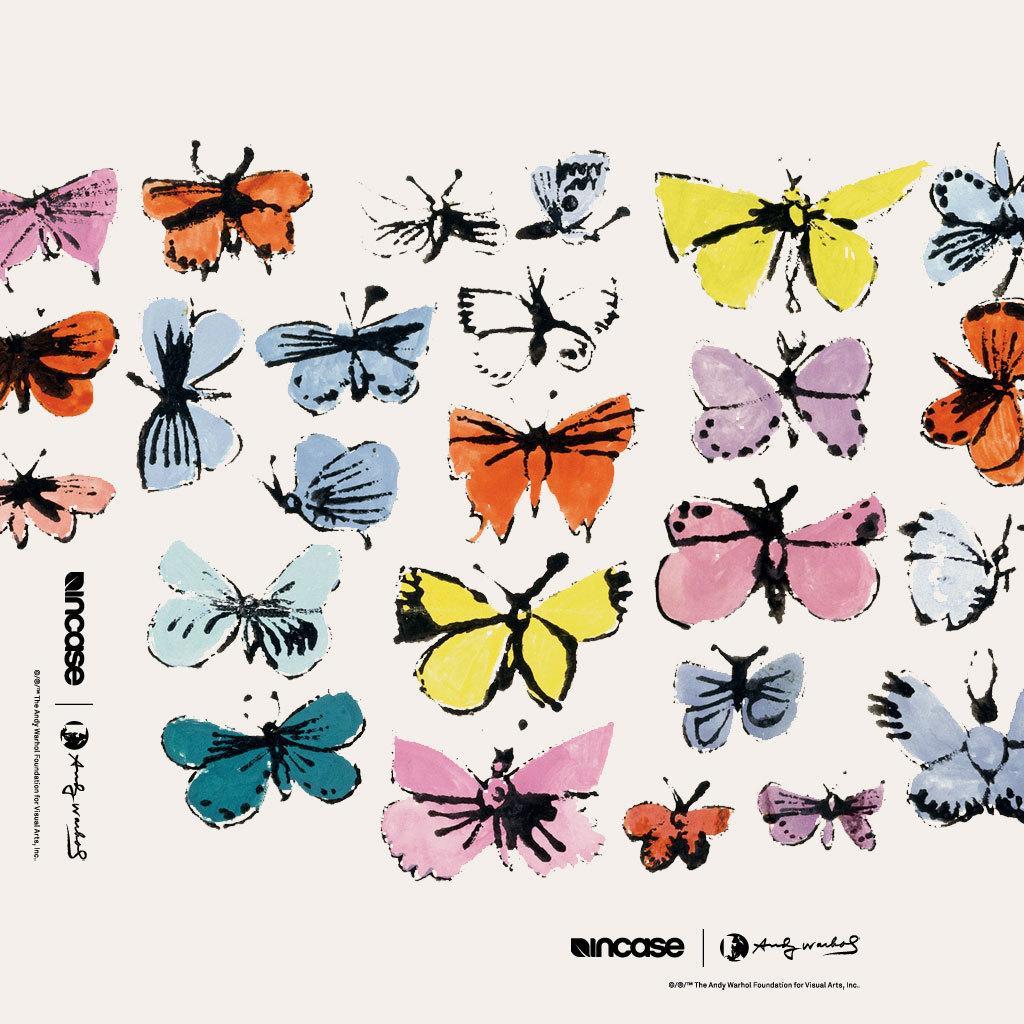Please provide a concise description of this image. In this image we can see the sketch of few butterflies and some text on the paper. 